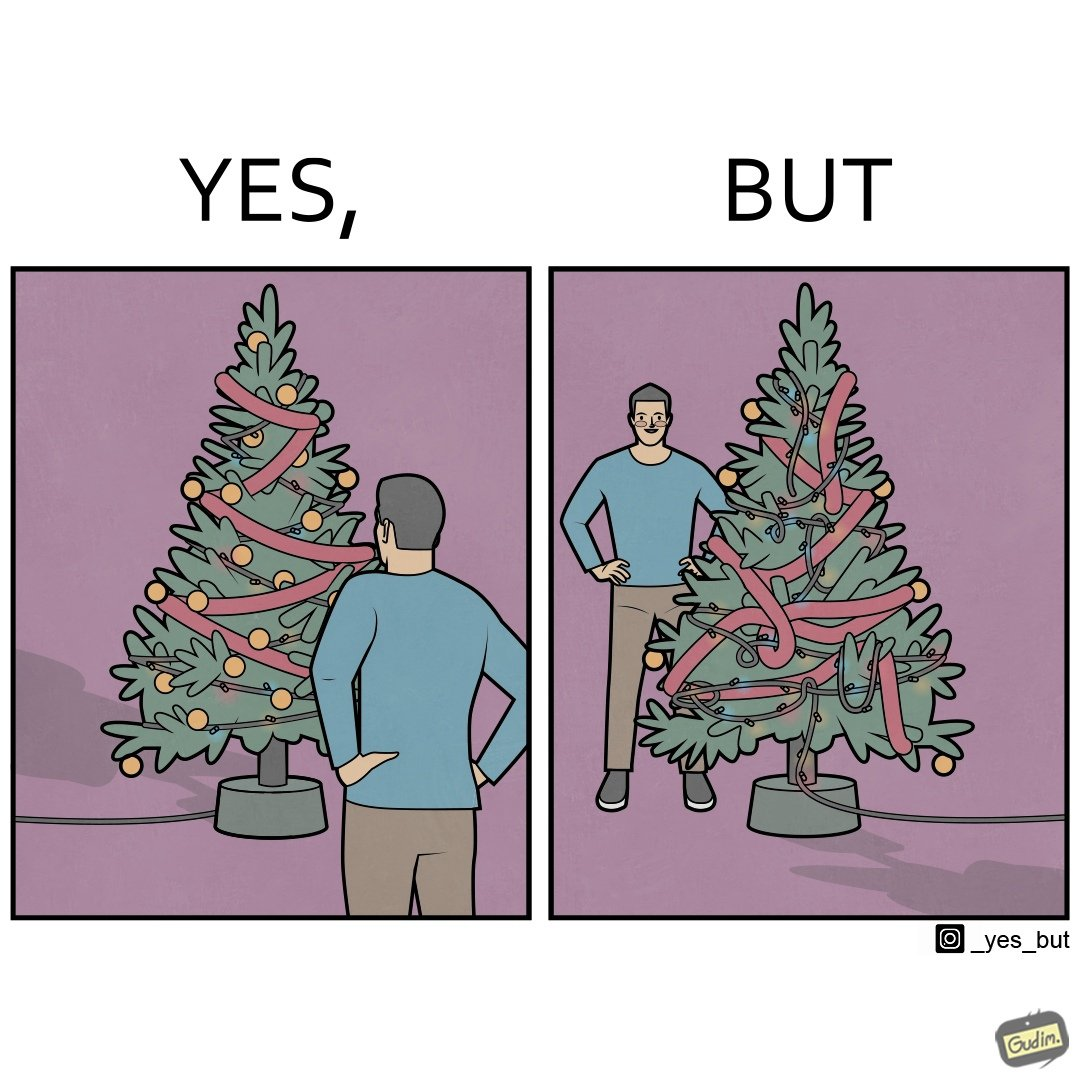Provide a description of this image. The image is ironic, because in the first image a person is seen watching his decorated X-mas tree but in the second image it is shown that the tree is looking beautiful not due to its natural beauty but the bulbs connected via power decorated over it 